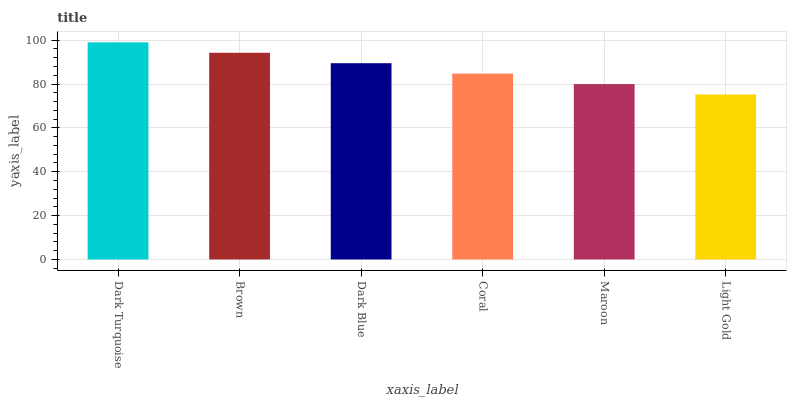Is Light Gold the minimum?
Answer yes or no. Yes. Is Dark Turquoise the maximum?
Answer yes or no. Yes. Is Brown the minimum?
Answer yes or no. No. Is Brown the maximum?
Answer yes or no. No. Is Dark Turquoise greater than Brown?
Answer yes or no. Yes. Is Brown less than Dark Turquoise?
Answer yes or no. Yes. Is Brown greater than Dark Turquoise?
Answer yes or no. No. Is Dark Turquoise less than Brown?
Answer yes or no. No. Is Dark Blue the high median?
Answer yes or no. Yes. Is Coral the low median?
Answer yes or no. Yes. Is Light Gold the high median?
Answer yes or no. No. Is Brown the low median?
Answer yes or no. No. 